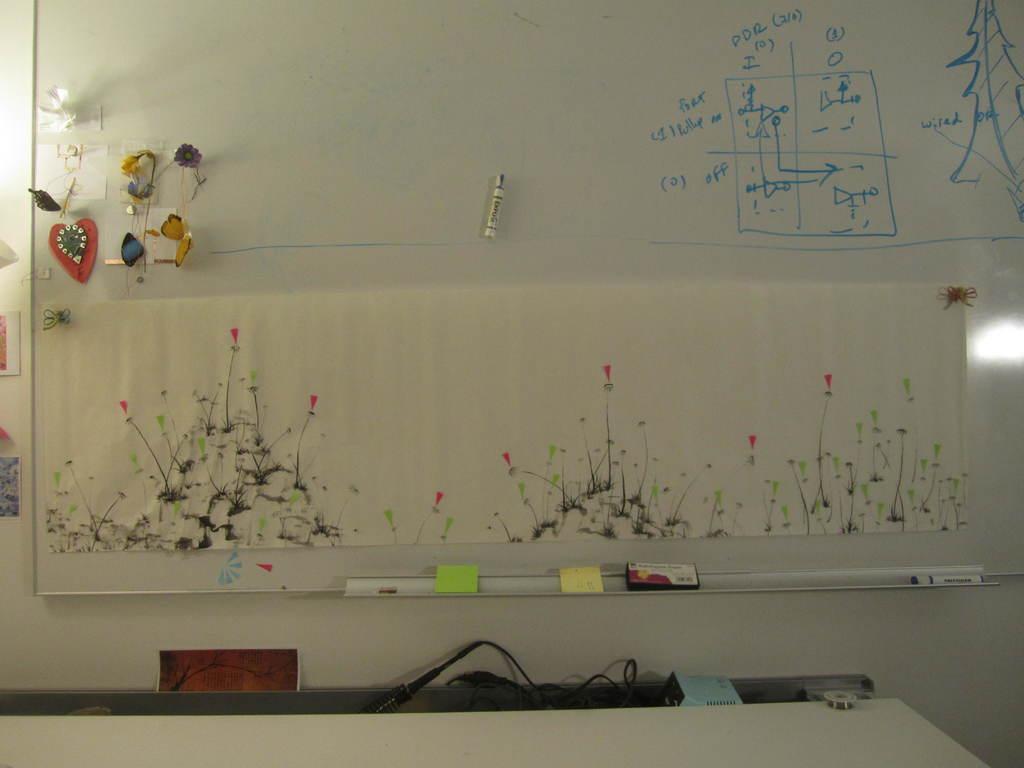Please provide a concise description of this image. There is a board and on the board there is some art work is done,beside that there are some diagrams drawn with a sketch pen and in the background there is a wall. 